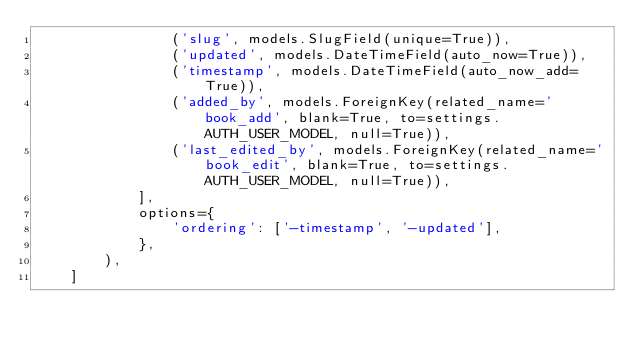Convert code to text. <code><loc_0><loc_0><loc_500><loc_500><_Python_>                ('slug', models.SlugField(unique=True)),
                ('updated', models.DateTimeField(auto_now=True)),
                ('timestamp', models.DateTimeField(auto_now_add=True)),
                ('added_by', models.ForeignKey(related_name='book_add', blank=True, to=settings.AUTH_USER_MODEL, null=True)),
                ('last_edited_by', models.ForeignKey(related_name='book_edit', blank=True, to=settings.AUTH_USER_MODEL, null=True)),
            ],
            options={
                'ordering': ['-timestamp', '-updated'],
            },
        ),
    ]
</code> 